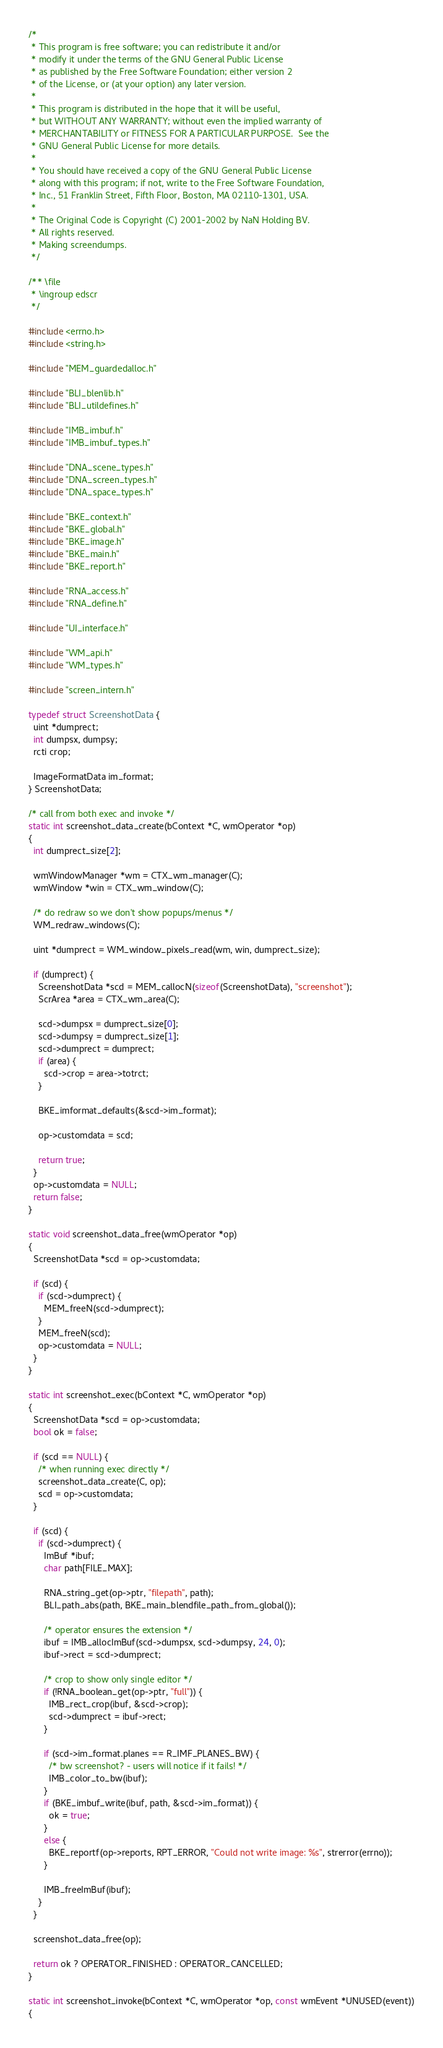Convert code to text. <code><loc_0><loc_0><loc_500><loc_500><_C_>/*
 * This program is free software; you can redistribute it and/or
 * modify it under the terms of the GNU General Public License
 * as published by the Free Software Foundation; either version 2
 * of the License, or (at your option) any later version.
 *
 * This program is distributed in the hope that it will be useful,
 * but WITHOUT ANY WARRANTY; without even the implied warranty of
 * MERCHANTABILITY or FITNESS FOR A PARTICULAR PURPOSE.  See the
 * GNU General Public License for more details.
 *
 * You should have received a copy of the GNU General Public License
 * along with this program; if not, write to the Free Software Foundation,
 * Inc., 51 Franklin Street, Fifth Floor, Boston, MA 02110-1301, USA.
 *
 * The Original Code is Copyright (C) 2001-2002 by NaN Holding BV.
 * All rights reserved.
 * Making screendumps.
 */

/** \file
 * \ingroup edscr
 */

#include <errno.h>
#include <string.h>

#include "MEM_guardedalloc.h"

#include "BLI_blenlib.h"
#include "BLI_utildefines.h"

#include "IMB_imbuf.h"
#include "IMB_imbuf_types.h"

#include "DNA_scene_types.h"
#include "DNA_screen_types.h"
#include "DNA_space_types.h"

#include "BKE_context.h"
#include "BKE_global.h"
#include "BKE_image.h"
#include "BKE_main.h"
#include "BKE_report.h"

#include "RNA_access.h"
#include "RNA_define.h"

#include "UI_interface.h"

#include "WM_api.h"
#include "WM_types.h"

#include "screen_intern.h"

typedef struct ScreenshotData {
  uint *dumprect;
  int dumpsx, dumpsy;
  rcti crop;

  ImageFormatData im_format;
} ScreenshotData;

/* call from both exec and invoke */
static int screenshot_data_create(bContext *C, wmOperator *op)
{
  int dumprect_size[2];

  wmWindowManager *wm = CTX_wm_manager(C);
  wmWindow *win = CTX_wm_window(C);

  /* do redraw so we don't show popups/menus */
  WM_redraw_windows(C);

  uint *dumprect = WM_window_pixels_read(wm, win, dumprect_size);

  if (dumprect) {
    ScreenshotData *scd = MEM_callocN(sizeof(ScreenshotData), "screenshot");
    ScrArea *area = CTX_wm_area(C);

    scd->dumpsx = dumprect_size[0];
    scd->dumpsy = dumprect_size[1];
    scd->dumprect = dumprect;
    if (area) {
      scd->crop = area->totrct;
    }

    BKE_imformat_defaults(&scd->im_format);

    op->customdata = scd;

    return true;
  }
  op->customdata = NULL;
  return false;
}

static void screenshot_data_free(wmOperator *op)
{
  ScreenshotData *scd = op->customdata;

  if (scd) {
    if (scd->dumprect) {
      MEM_freeN(scd->dumprect);
    }
    MEM_freeN(scd);
    op->customdata = NULL;
  }
}

static int screenshot_exec(bContext *C, wmOperator *op)
{
  ScreenshotData *scd = op->customdata;
  bool ok = false;

  if (scd == NULL) {
    /* when running exec directly */
    screenshot_data_create(C, op);
    scd = op->customdata;
  }

  if (scd) {
    if (scd->dumprect) {
      ImBuf *ibuf;
      char path[FILE_MAX];

      RNA_string_get(op->ptr, "filepath", path);
      BLI_path_abs(path, BKE_main_blendfile_path_from_global());

      /* operator ensures the extension */
      ibuf = IMB_allocImBuf(scd->dumpsx, scd->dumpsy, 24, 0);
      ibuf->rect = scd->dumprect;

      /* crop to show only single editor */
      if (!RNA_boolean_get(op->ptr, "full")) {
        IMB_rect_crop(ibuf, &scd->crop);
        scd->dumprect = ibuf->rect;
      }

      if (scd->im_format.planes == R_IMF_PLANES_BW) {
        /* bw screenshot? - users will notice if it fails! */
        IMB_color_to_bw(ibuf);
      }
      if (BKE_imbuf_write(ibuf, path, &scd->im_format)) {
        ok = true;
      }
      else {
        BKE_reportf(op->reports, RPT_ERROR, "Could not write image: %s", strerror(errno));
      }

      IMB_freeImBuf(ibuf);
    }
  }

  screenshot_data_free(op);

  return ok ? OPERATOR_FINISHED : OPERATOR_CANCELLED;
}

static int screenshot_invoke(bContext *C, wmOperator *op, const wmEvent *UNUSED(event))
{</code> 